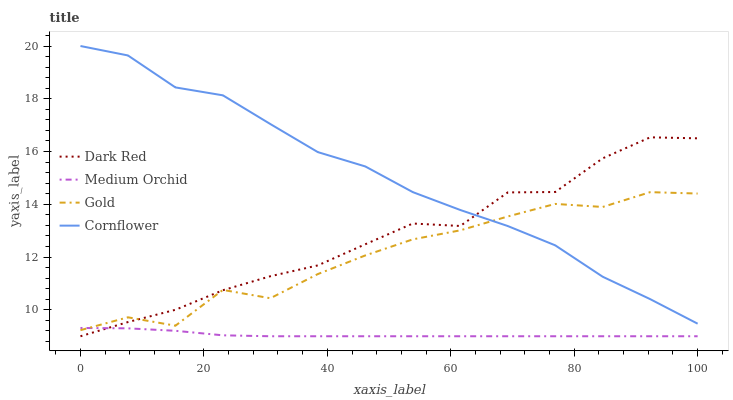Does Medium Orchid have the minimum area under the curve?
Answer yes or no. Yes. Does Cornflower have the maximum area under the curve?
Answer yes or no. Yes. Does Gold have the minimum area under the curve?
Answer yes or no. No. Does Gold have the maximum area under the curve?
Answer yes or no. No. Is Medium Orchid the smoothest?
Answer yes or no. Yes. Is Gold the roughest?
Answer yes or no. Yes. Is Gold the smoothest?
Answer yes or no. No. Is Medium Orchid the roughest?
Answer yes or no. No. Does Dark Red have the lowest value?
Answer yes or no. Yes. Does Gold have the lowest value?
Answer yes or no. No. Does Cornflower have the highest value?
Answer yes or no. Yes. Does Gold have the highest value?
Answer yes or no. No. Is Medium Orchid less than Cornflower?
Answer yes or no. Yes. Is Cornflower greater than Medium Orchid?
Answer yes or no. Yes. Does Dark Red intersect Cornflower?
Answer yes or no. Yes. Is Dark Red less than Cornflower?
Answer yes or no. No. Is Dark Red greater than Cornflower?
Answer yes or no. No. Does Medium Orchid intersect Cornflower?
Answer yes or no. No. 